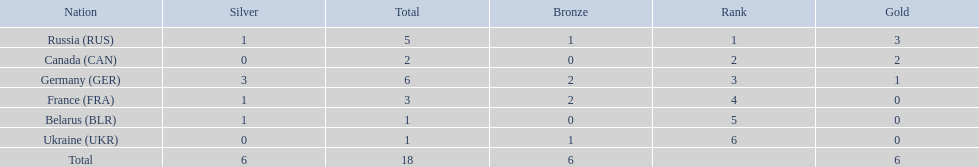Which countries competed in the 1995 biathlon? Russia (RUS), Canada (CAN), Germany (GER), France (FRA), Belarus (BLR), Ukraine (UKR). How many medals in total did they win? 5, 2, 6, 3, 1, 1. And which country had the most? Germany (GER). 